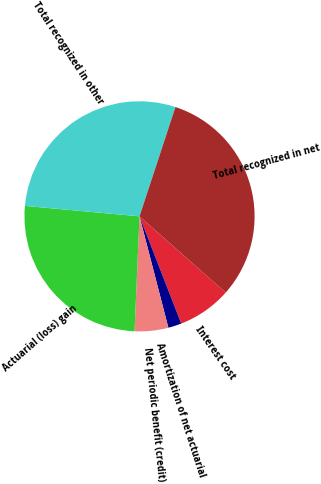Convert chart. <chart><loc_0><loc_0><loc_500><loc_500><pie_chart><fcel>Interest cost<fcel>Amortization of net actuarial<fcel>Net periodic benefit (credit)<fcel>Actuarial (loss) gain<fcel>Total recognized in other<fcel>Total recognized in net<nl><fcel>7.57%<fcel>1.87%<fcel>4.72%<fcel>25.76%<fcel>28.61%<fcel>31.47%<nl></chart> 